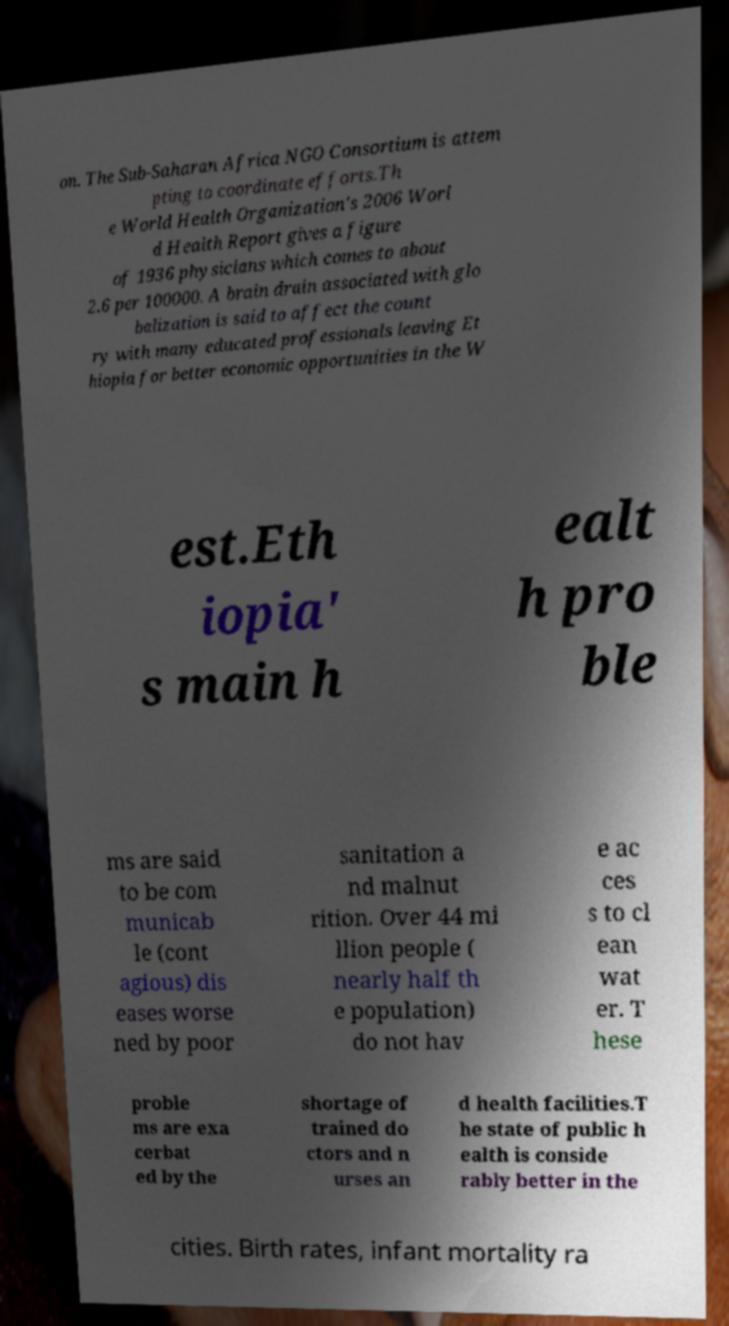What messages or text are displayed in this image? I need them in a readable, typed format. on. The Sub-Saharan Africa NGO Consortium is attem pting to coordinate efforts.Th e World Health Organization's 2006 Worl d Health Report gives a figure of 1936 physicians which comes to about 2.6 per 100000. A brain drain associated with glo balization is said to affect the count ry with many educated professionals leaving Et hiopia for better economic opportunities in the W est.Eth iopia' s main h ealt h pro ble ms are said to be com municab le (cont agious) dis eases worse ned by poor sanitation a nd malnut rition. Over 44 mi llion people ( nearly half th e population) do not hav e ac ces s to cl ean wat er. T hese proble ms are exa cerbat ed by the shortage of trained do ctors and n urses an d health facilities.T he state of public h ealth is conside rably better in the cities. Birth rates, infant mortality ra 